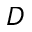Convert formula to latex. <formula><loc_0><loc_0><loc_500><loc_500>D</formula> 